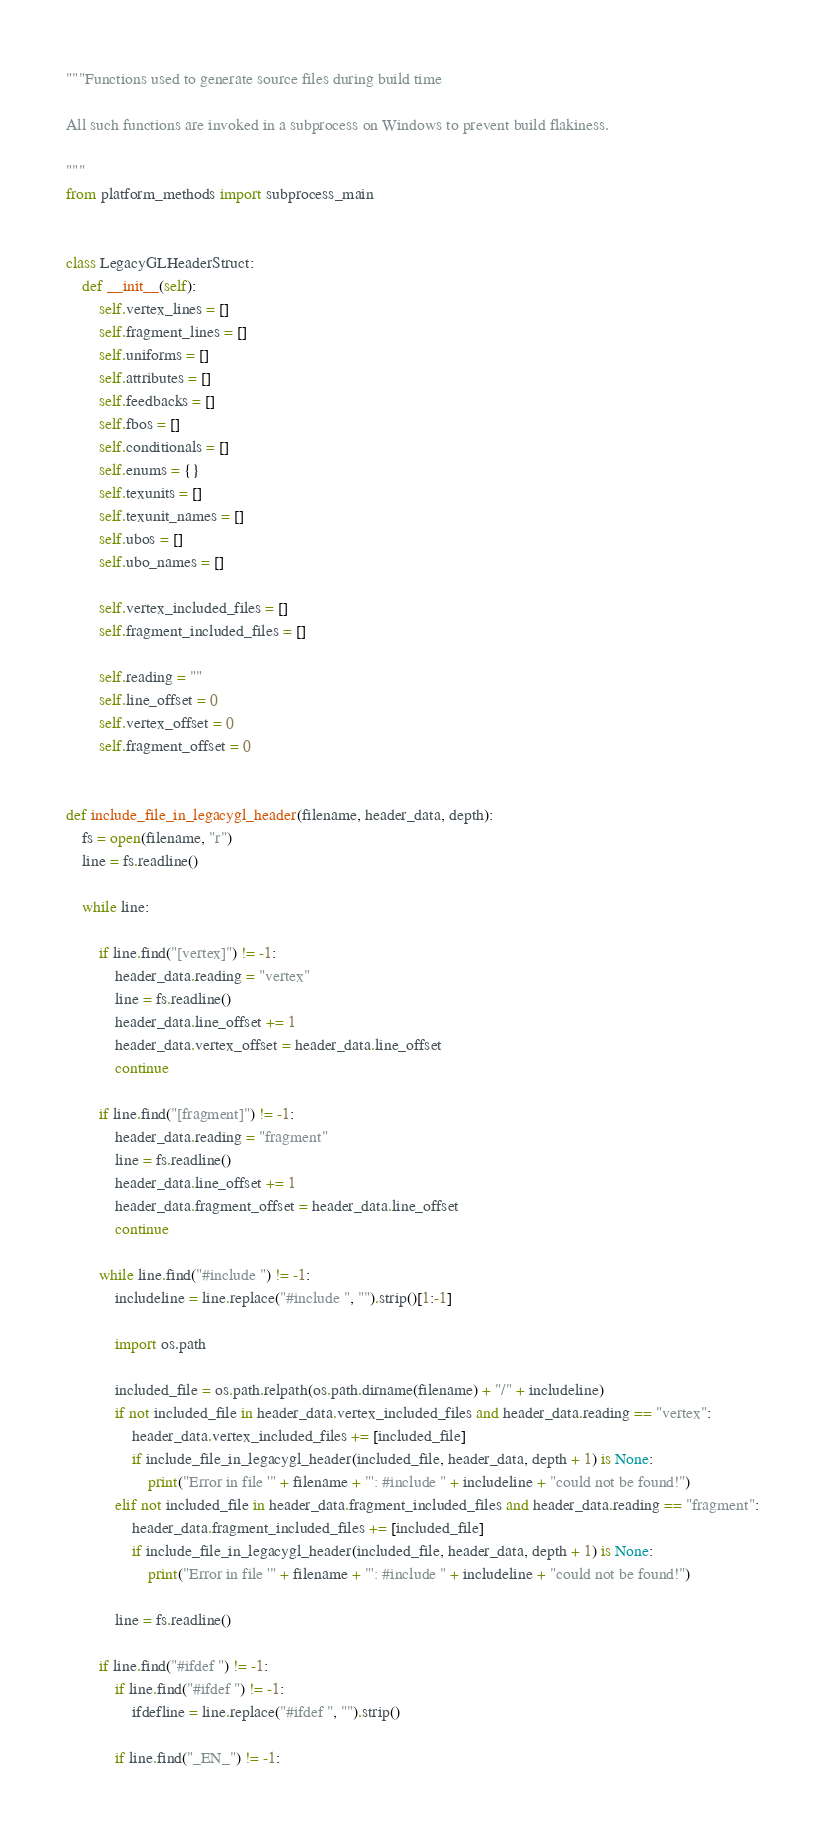Convert code to text. <code><loc_0><loc_0><loc_500><loc_500><_Python_>"""Functions used to generate source files during build time

All such functions are invoked in a subprocess on Windows to prevent build flakiness.

"""
from platform_methods import subprocess_main


class LegacyGLHeaderStruct:
    def __init__(self):
        self.vertex_lines = []
        self.fragment_lines = []
        self.uniforms = []
        self.attributes = []
        self.feedbacks = []
        self.fbos = []
        self.conditionals = []
        self.enums = {}
        self.texunits = []
        self.texunit_names = []
        self.ubos = []
        self.ubo_names = []

        self.vertex_included_files = []
        self.fragment_included_files = []

        self.reading = ""
        self.line_offset = 0
        self.vertex_offset = 0
        self.fragment_offset = 0


def include_file_in_legacygl_header(filename, header_data, depth):
    fs = open(filename, "r")
    line = fs.readline()

    while line:

        if line.find("[vertex]") != -1:
            header_data.reading = "vertex"
            line = fs.readline()
            header_data.line_offset += 1
            header_data.vertex_offset = header_data.line_offset
            continue

        if line.find("[fragment]") != -1:
            header_data.reading = "fragment"
            line = fs.readline()
            header_data.line_offset += 1
            header_data.fragment_offset = header_data.line_offset
            continue

        while line.find("#include ") != -1:
            includeline = line.replace("#include ", "").strip()[1:-1]

            import os.path

            included_file = os.path.relpath(os.path.dirname(filename) + "/" + includeline)
            if not included_file in header_data.vertex_included_files and header_data.reading == "vertex":
                header_data.vertex_included_files += [included_file]
                if include_file_in_legacygl_header(included_file, header_data, depth + 1) is None:
                    print("Error in file '" + filename + "': #include " + includeline + "could not be found!")
            elif not included_file in header_data.fragment_included_files and header_data.reading == "fragment":
                header_data.fragment_included_files += [included_file]
                if include_file_in_legacygl_header(included_file, header_data, depth + 1) is None:
                    print("Error in file '" + filename + "': #include " + includeline + "could not be found!")

            line = fs.readline()

        if line.find("#ifdef ") != -1:
            if line.find("#ifdef ") != -1:
                ifdefline = line.replace("#ifdef ", "").strip()

            if line.find("_EN_") != -1:</code> 